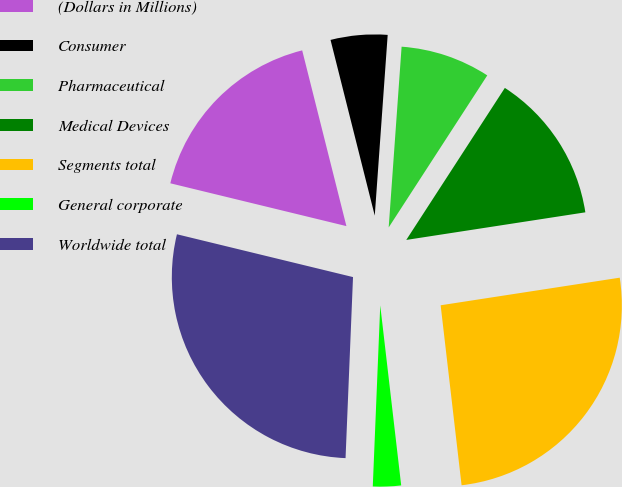Convert chart to OTSL. <chart><loc_0><loc_0><loc_500><loc_500><pie_chart><fcel>(Dollars in Millions)<fcel>Consumer<fcel>Pharmaceutical<fcel>Medical Devices<fcel>Segments total<fcel>General corporate<fcel>Worldwide total<nl><fcel>17.28%<fcel>5.06%<fcel>8.02%<fcel>13.41%<fcel>25.59%<fcel>2.5%<fcel>28.14%<nl></chart> 